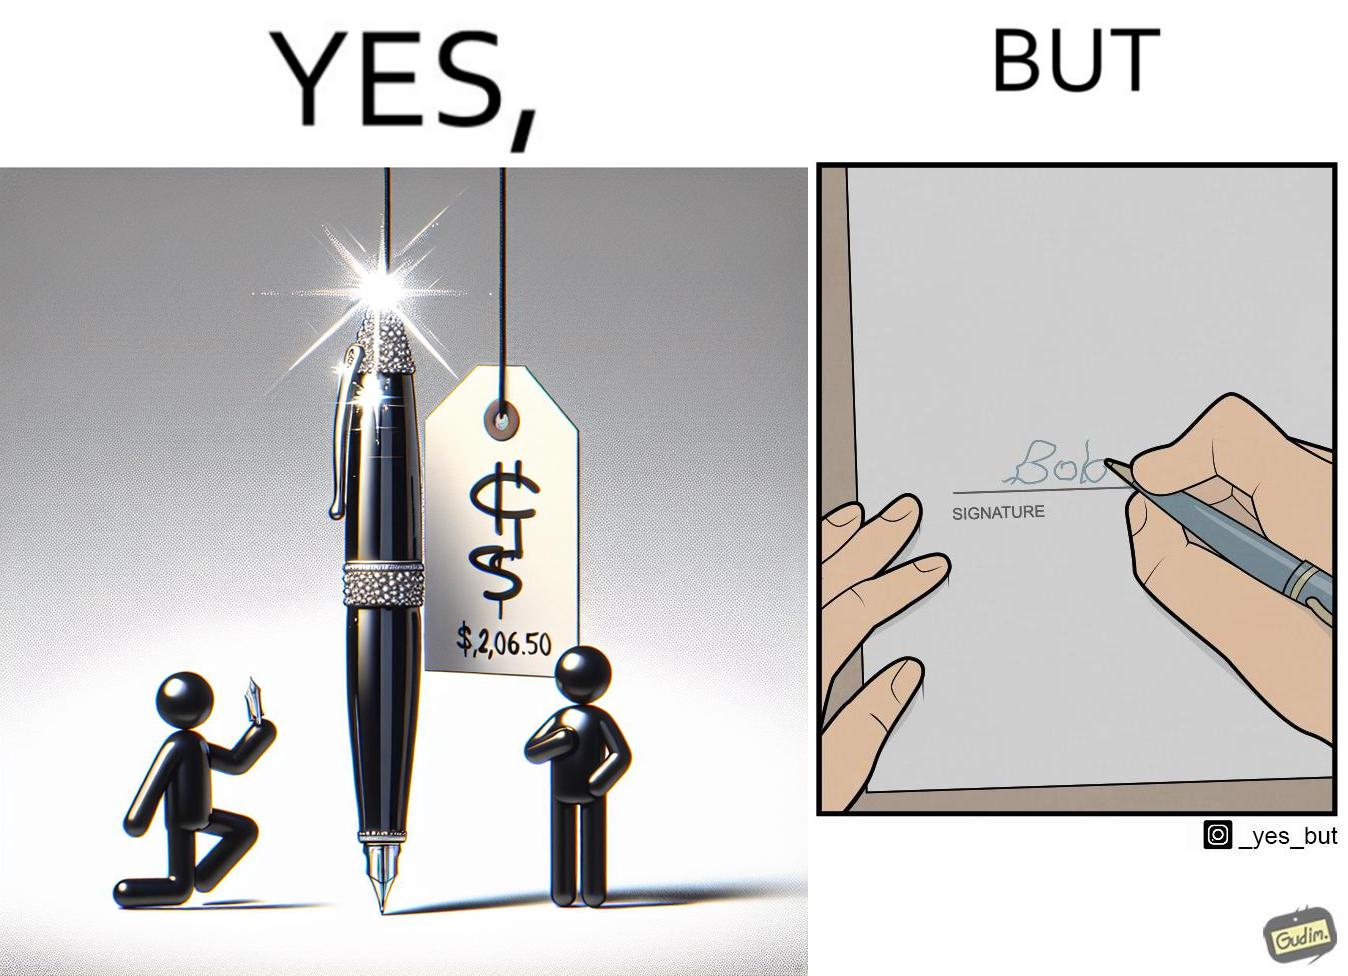Does this image contain satire or humor? Yes, this image is satirical. 